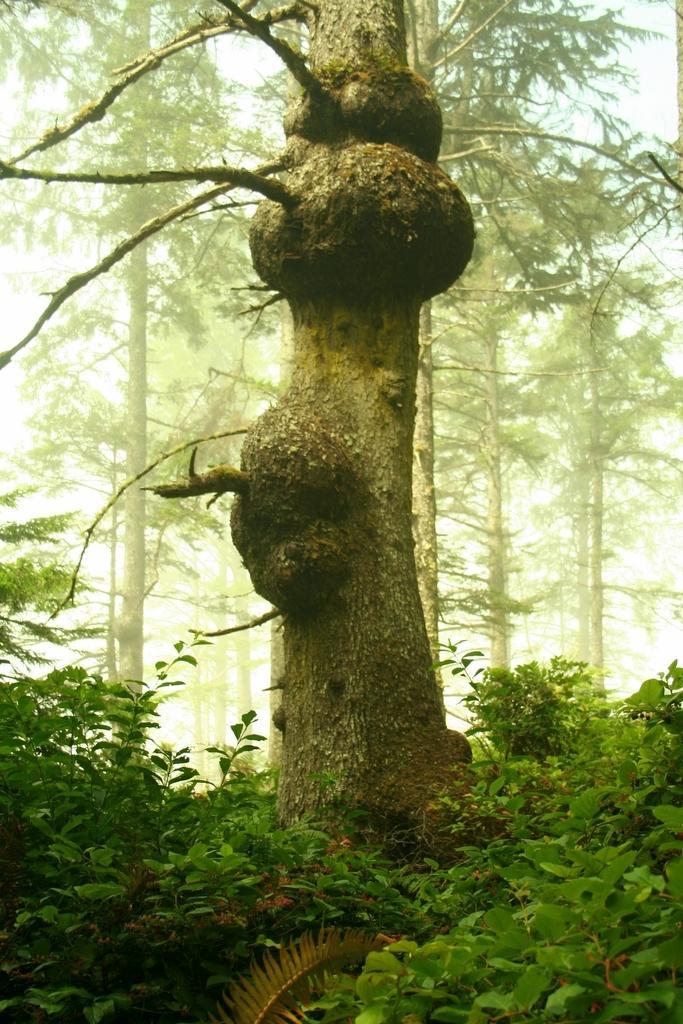Can you describe this image briefly? In this image there is a tree trunk and around that there are plants and also there are trees at back. 